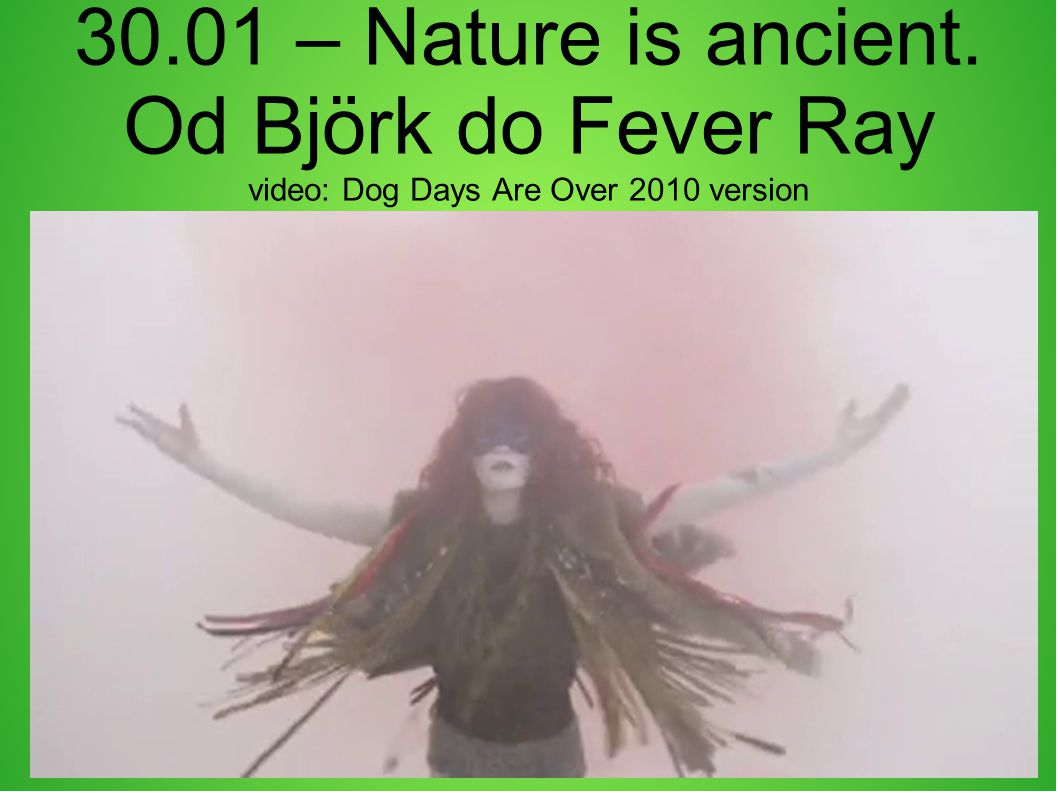If this figure had a motto, what would it be? The figure's motto might be: 'Embrace the ancient, transcend the present.' This reflects their deep connection to timeless wisdom and their role in guiding others through personal and collective transformation. 